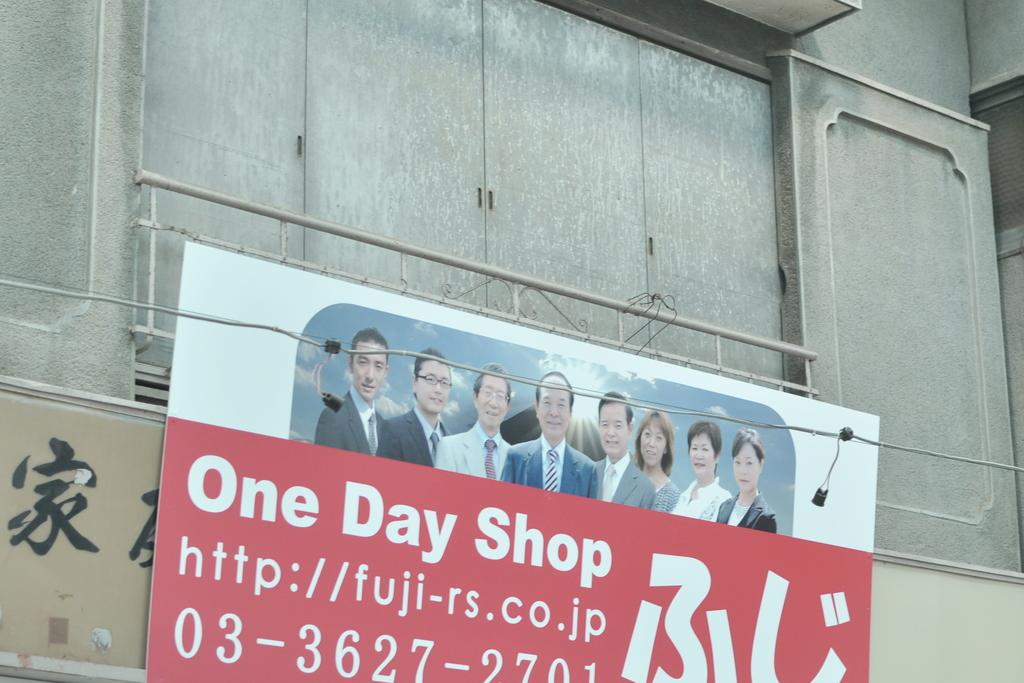Provide a one-sentence caption for the provided image. A sign for something called the One Day Shop. 